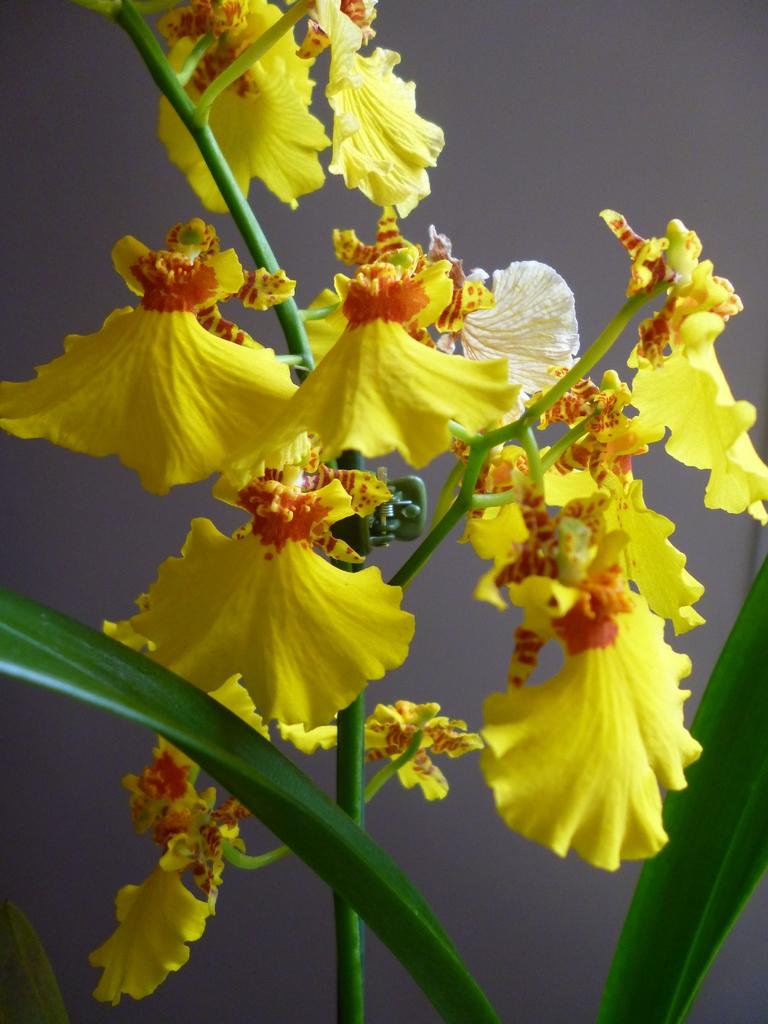What type of flowers can be seen in the image? There are yellow flowers in the image. How are the flowers attached to the stem? The flowers are on a stem. What other parts of the plant are visible in the image? There are two leaves visible at the bottom of the stem. What type of tent can be seen in the image? There is no tent present in the image; it features yellow flowers on a stem with leaves. 